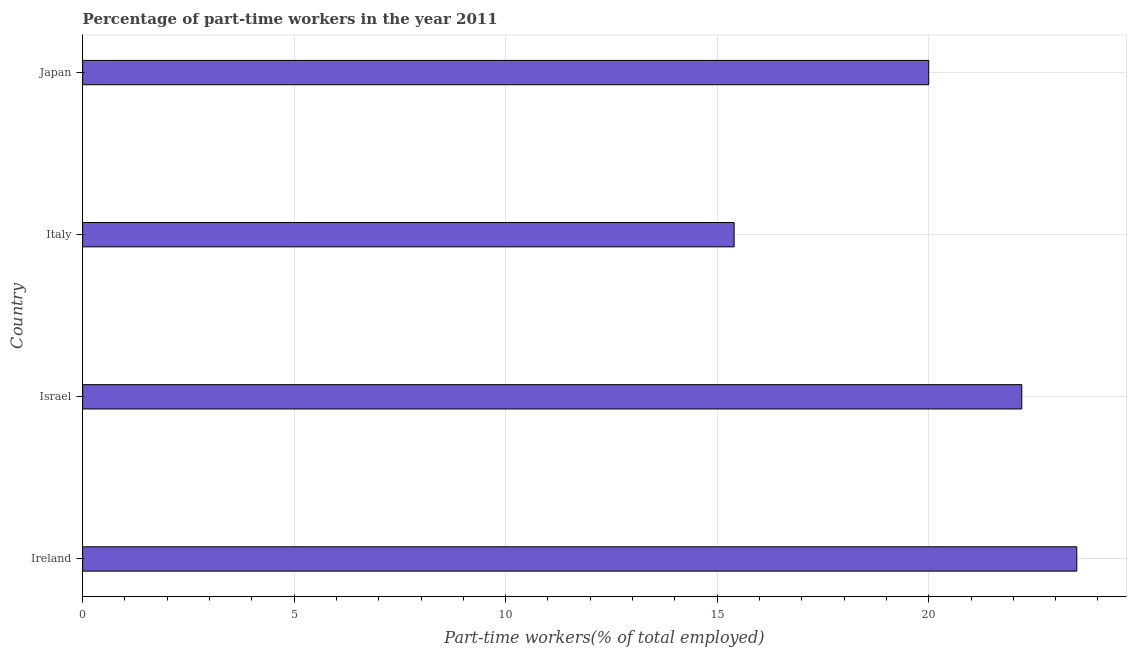What is the title of the graph?
Provide a short and direct response. Percentage of part-time workers in the year 2011. What is the label or title of the X-axis?
Give a very brief answer. Part-time workers(% of total employed). Across all countries, what is the maximum percentage of part-time workers?
Ensure brevity in your answer.  23.5. Across all countries, what is the minimum percentage of part-time workers?
Give a very brief answer. 15.4. In which country was the percentage of part-time workers maximum?
Make the answer very short. Ireland. In which country was the percentage of part-time workers minimum?
Provide a short and direct response. Italy. What is the sum of the percentage of part-time workers?
Your answer should be compact. 81.1. What is the difference between the percentage of part-time workers in Ireland and Japan?
Offer a very short reply. 3.5. What is the average percentage of part-time workers per country?
Provide a short and direct response. 20.27. What is the median percentage of part-time workers?
Offer a very short reply. 21.1. In how many countries, is the percentage of part-time workers greater than 12 %?
Give a very brief answer. 4. What is the ratio of the percentage of part-time workers in Israel to that in Japan?
Ensure brevity in your answer.  1.11. Is the percentage of part-time workers in Ireland less than that in Israel?
Ensure brevity in your answer.  No. Is the difference between the percentage of part-time workers in Ireland and Japan greater than the difference between any two countries?
Your answer should be very brief. No. What is the difference between the highest and the second highest percentage of part-time workers?
Offer a terse response. 1.3. What is the difference between the highest and the lowest percentage of part-time workers?
Offer a terse response. 8.1. In how many countries, is the percentage of part-time workers greater than the average percentage of part-time workers taken over all countries?
Give a very brief answer. 2. How many bars are there?
Provide a short and direct response. 4. What is the Part-time workers(% of total employed) in Ireland?
Keep it short and to the point. 23.5. What is the Part-time workers(% of total employed) in Israel?
Provide a succinct answer. 22.2. What is the Part-time workers(% of total employed) in Italy?
Your answer should be compact. 15.4. What is the difference between the Part-time workers(% of total employed) in Ireland and Israel?
Make the answer very short. 1.3. What is the difference between the Part-time workers(% of total employed) in Ireland and Italy?
Keep it short and to the point. 8.1. What is the difference between the Part-time workers(% of total employed) in Israel and Italy?
Provide a succinct answer. 6.8. What is the ratio of the Part-time workers(% of total employed) in Ireland to that in Israel?
Your response must be concise. 1.06. What is the ratio of the Part-time workers(% of total employed) in Ireland to that in Italy?
Ensure brevity in your answer.  1.53. What is the ratio of the Part-time workers(% of total employed) in Ireland to that in Japan?
Provide a short and direct response. 1.18. What is the ratio of the Part-time workers(% of total employed) in Israel to that in Italy?
Your answer should be compact. 1.44. What is the ratio of the Part-time workers(% of total employed) in Israel to that in Japan?
Provide a succinct answer. 1.11. What is the ratio of the Part-time workers(% of total employed) in Italy to that in Japan?
Keep it short and to the point. 0.77. 